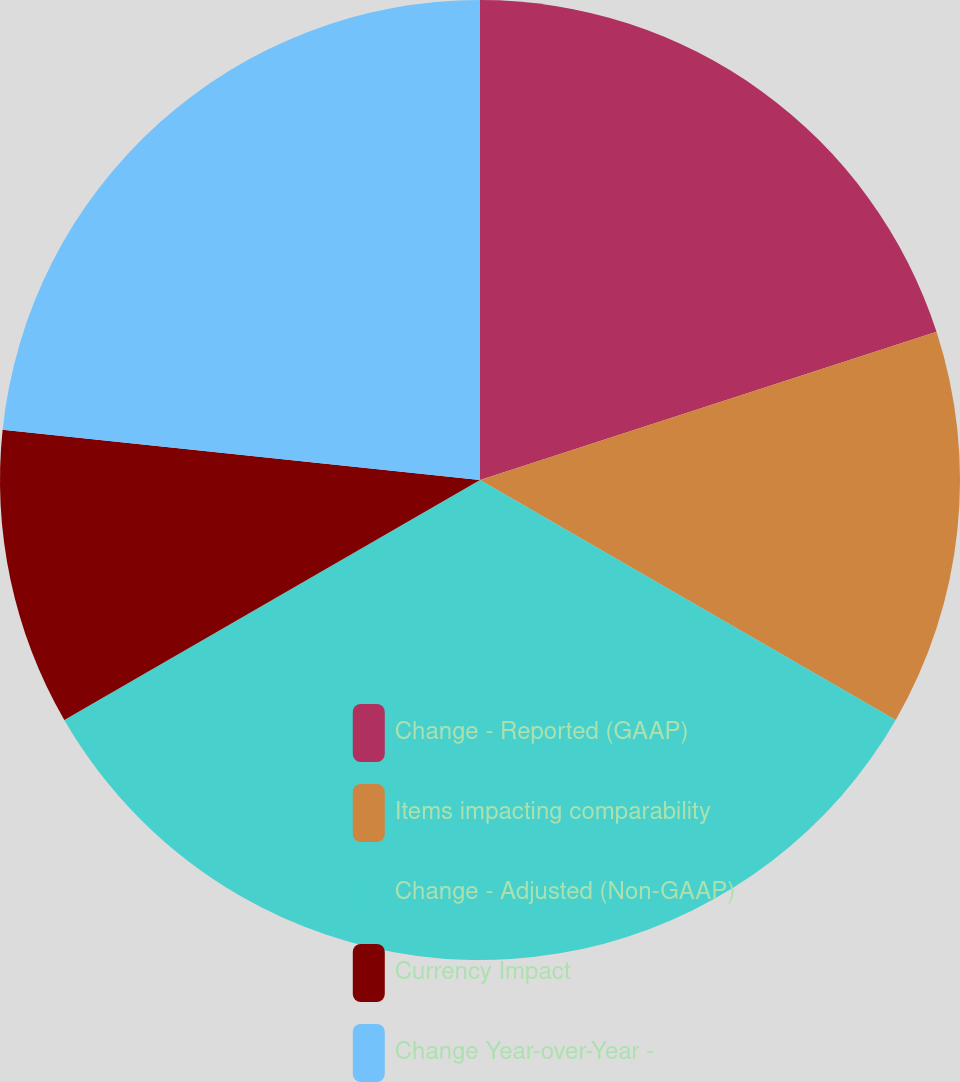<chart> <loc_0><loc_0><loc_500><loc_500><pie_chart><fcel>Change - Reported (GAAP)<fcel>Items impacting comparability<fcel>Change - Adjusted (Non-GAAP)<fcel>Currency Impact<fcel>Change Year-over-Year -<nl><fcel>20.0%<fcel>13.33%<fcel>33.33%<fcel>10.0%<fcel>23.33%<nl></chart> 